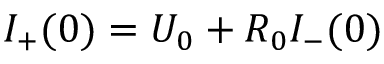<formula> <loc_0><loc_0><loc_500><loc_500>I _ { + } ( 0 ) = U _ { 0 } + R _ { 0 } I _ { - } ( 0 )</formula> 